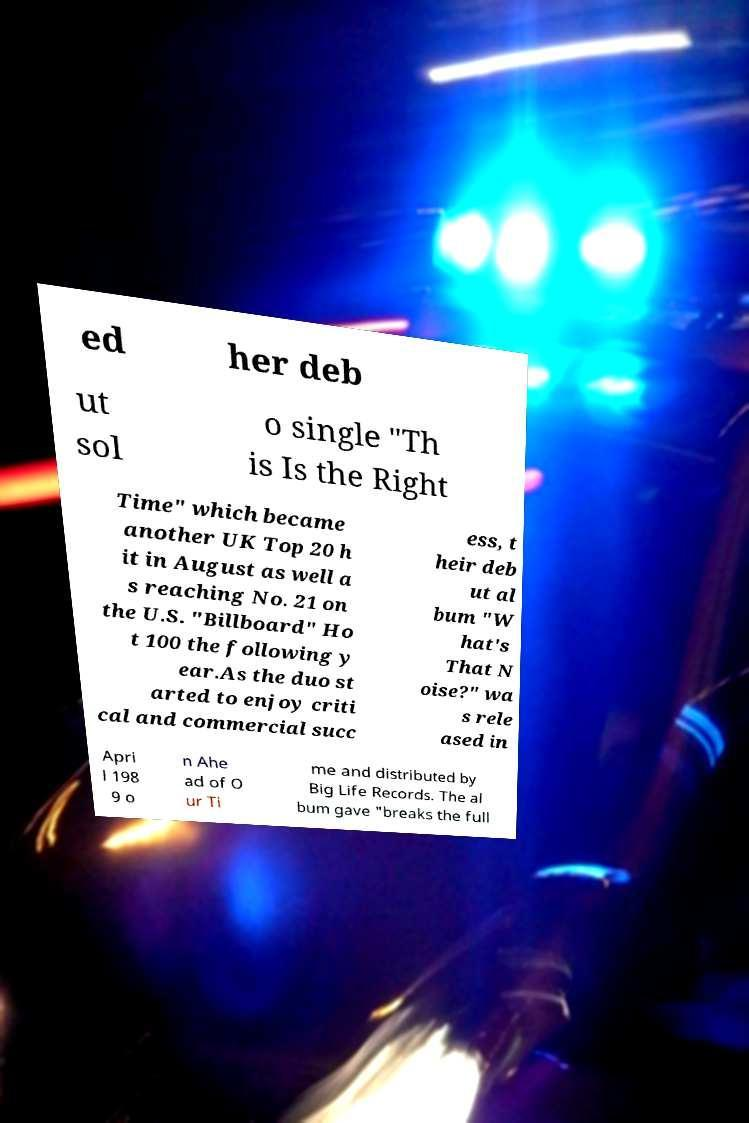What messages or text are displayed in this image? I need them in a readable, typed format. ed her deb ut sol o single "Th is Is the Right Time" which became another UK Top 20 h it in August as well a s reaching No. 21 on the U.S. "Billboard" Ho t 100 the following y ear.As the duo st arted to enjoy criti cal and commercial succ ess, t heir deb ut al bum "W hat's That N oise?" wa s rele ased in Apri l 198 9 o n Ahe ad of O ur Ti me and distributed by Big Life Records. The al bum gave "breaks the full 